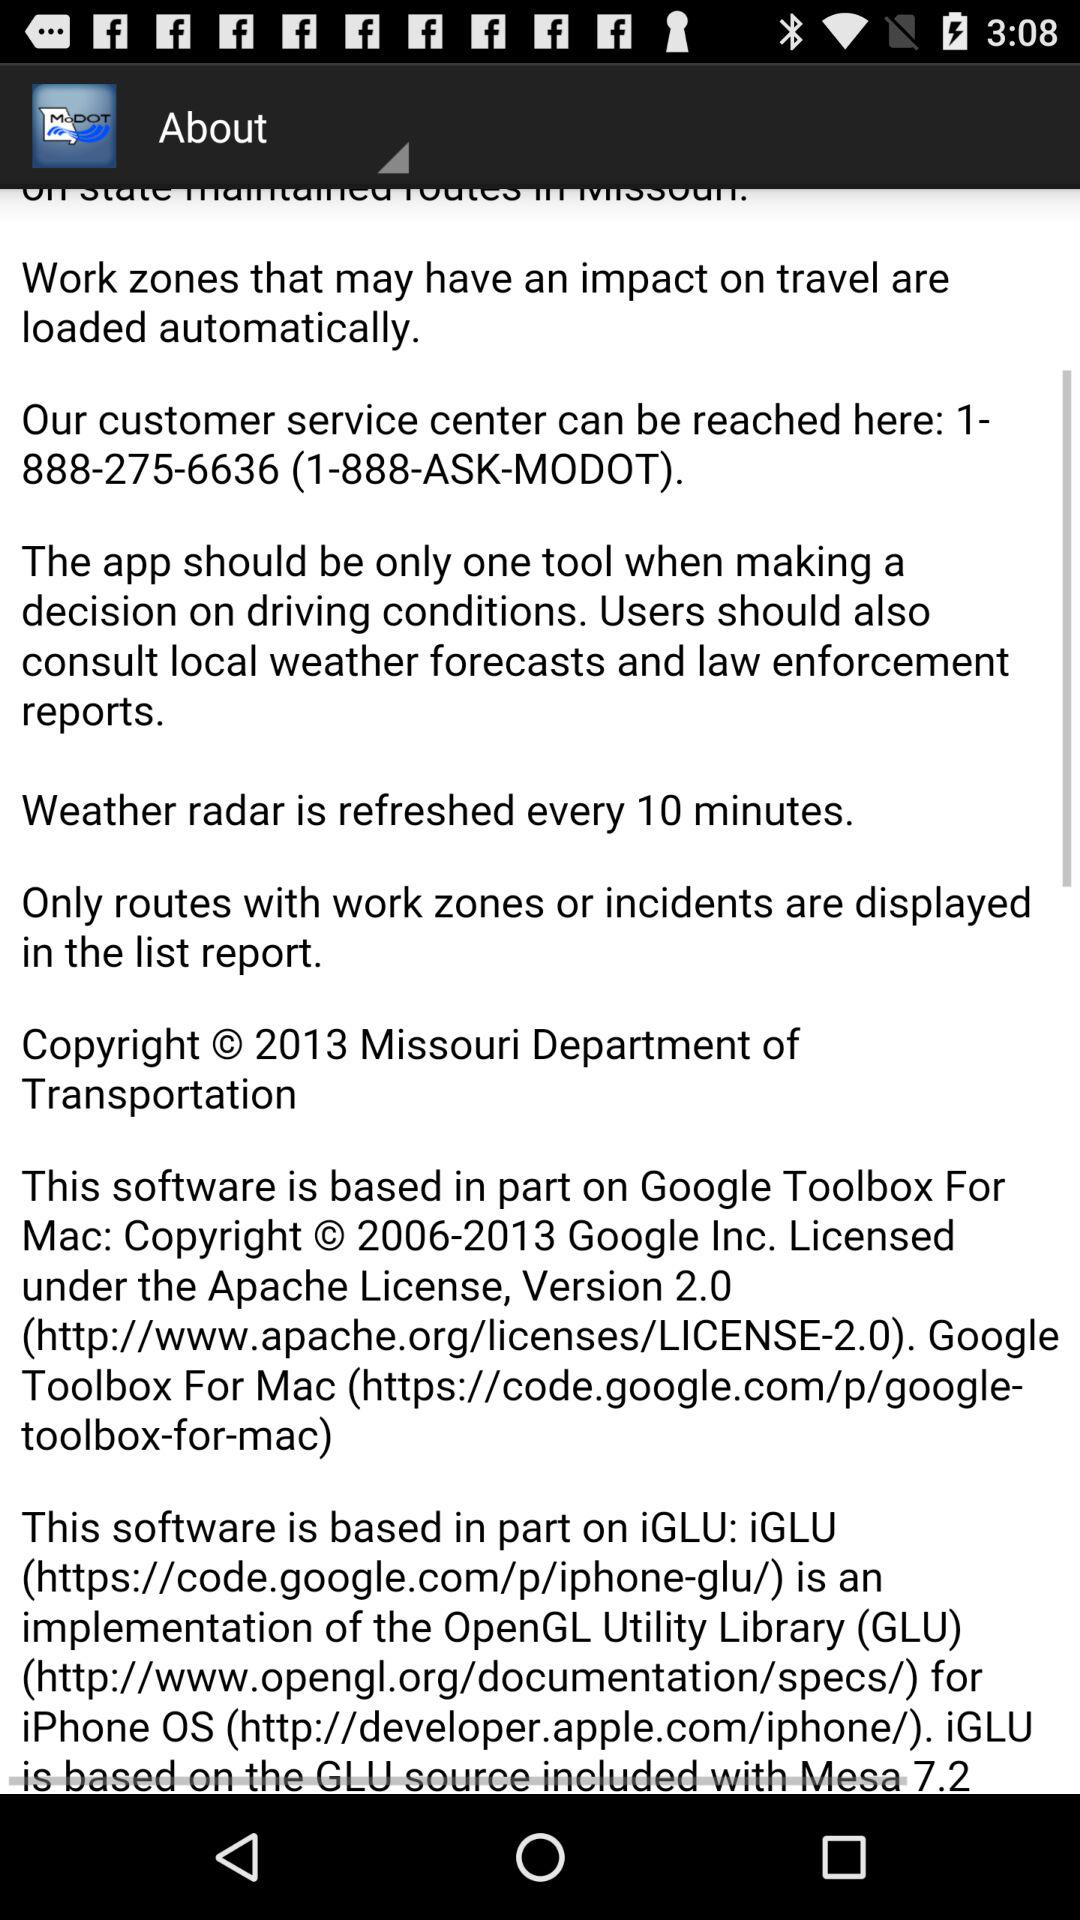What is the location of the weather radar?
When the provided information is insufficient, respond with <no answer>. <no answer> 